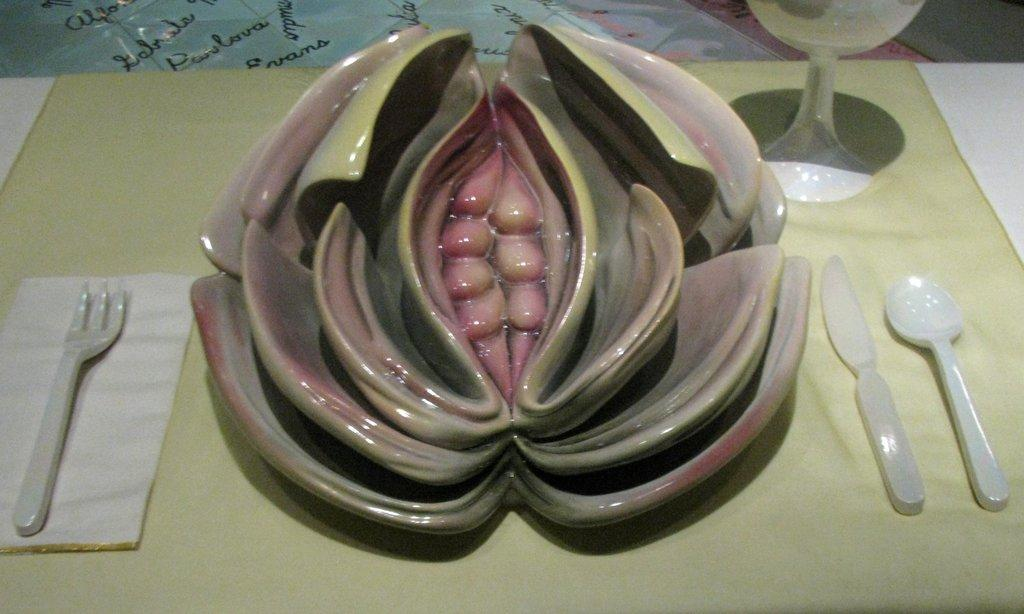What is the main object in the image? There is a bowl in the image. What else can be seen in the image besides the bowl? There are spoons and a cup visible in the image. Where are these objects located? All objects are on a table. What color is the uncle's hair in the image? There is no uncle present in the image, so it is not possible to determine the color of his hair. 